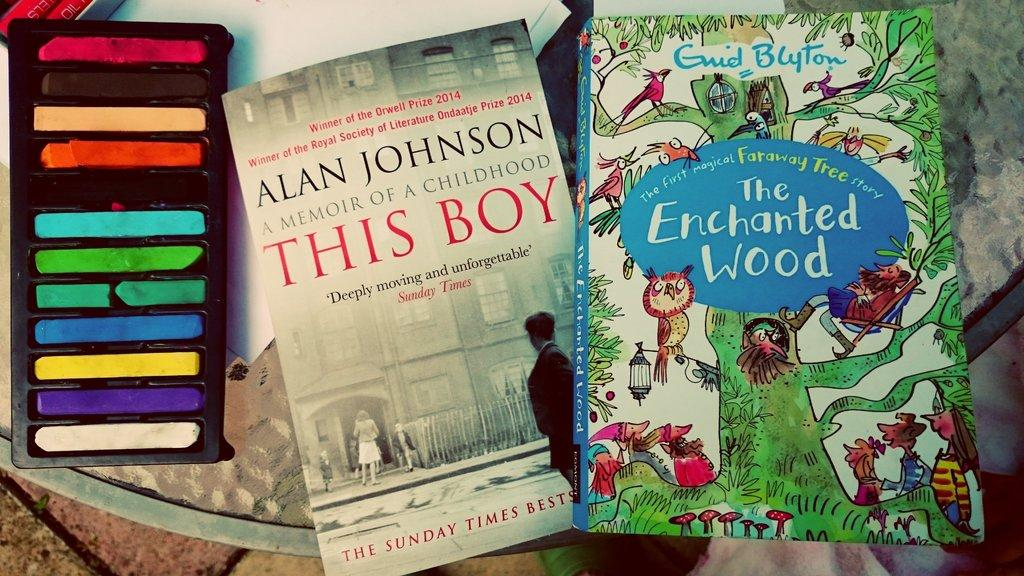<image>
Provide a brief description of the given image. The enchanted wood book and A memoir of a childhood this boy book. 